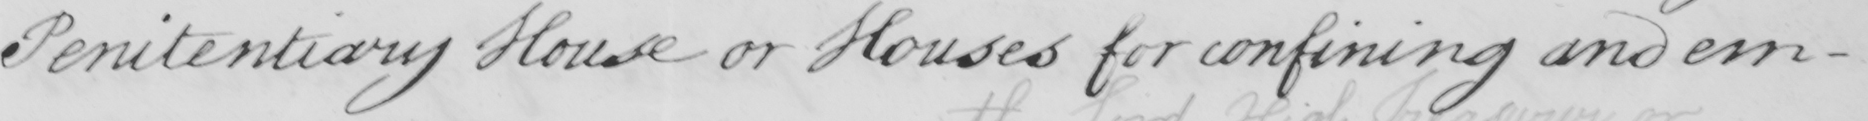Can you tell me what this handwritten text says? Penitentiary House or Houses for confining and em- 